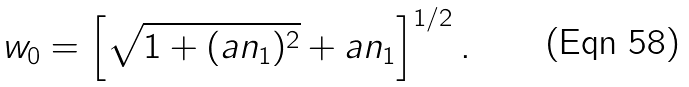<formula> <loc_0><loc_0><loc_500><loc_500>w _ { 0 } = \left [ \sqrt { 1 + ( a n _ { 1 } ) ^ { 2 } } + a n _ { 1 } \right ] ^ { 1 / 2 } .</formula> 